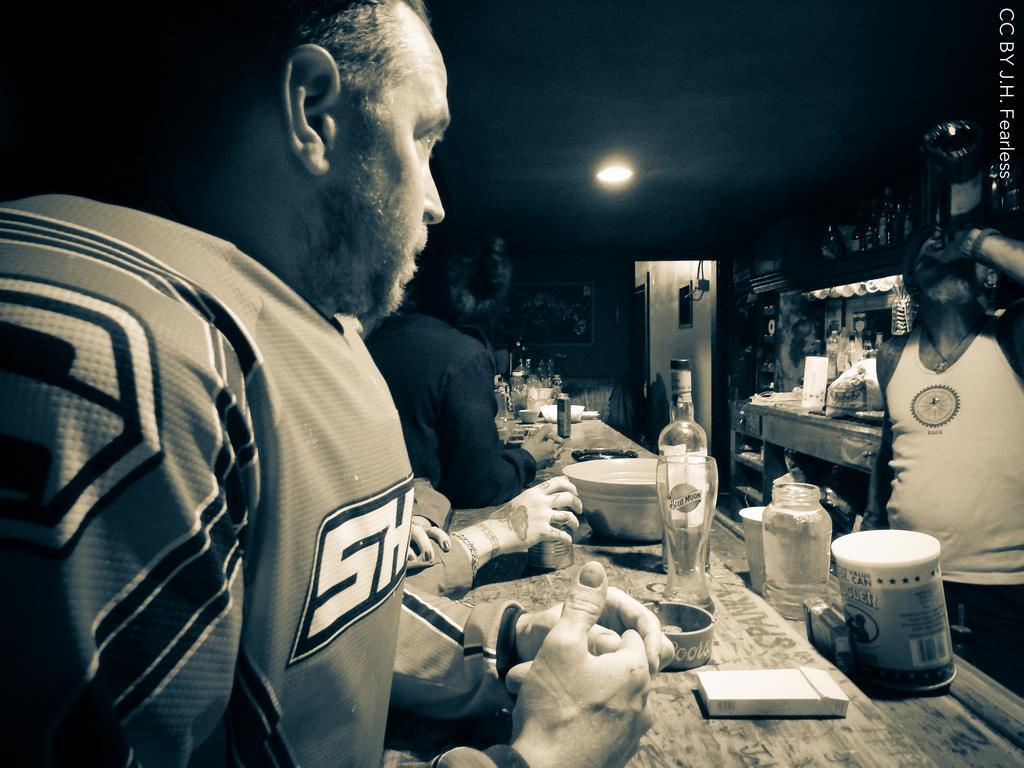How would you summarize this image in a sentence or two? Here we can see a person standing on the right side and he is drinking a wine. This is a wooden table a glass and a wine bottle are kept on it. Here we can see two persons on the left side. Here we can see a few wine bottles which are on the top right side. 